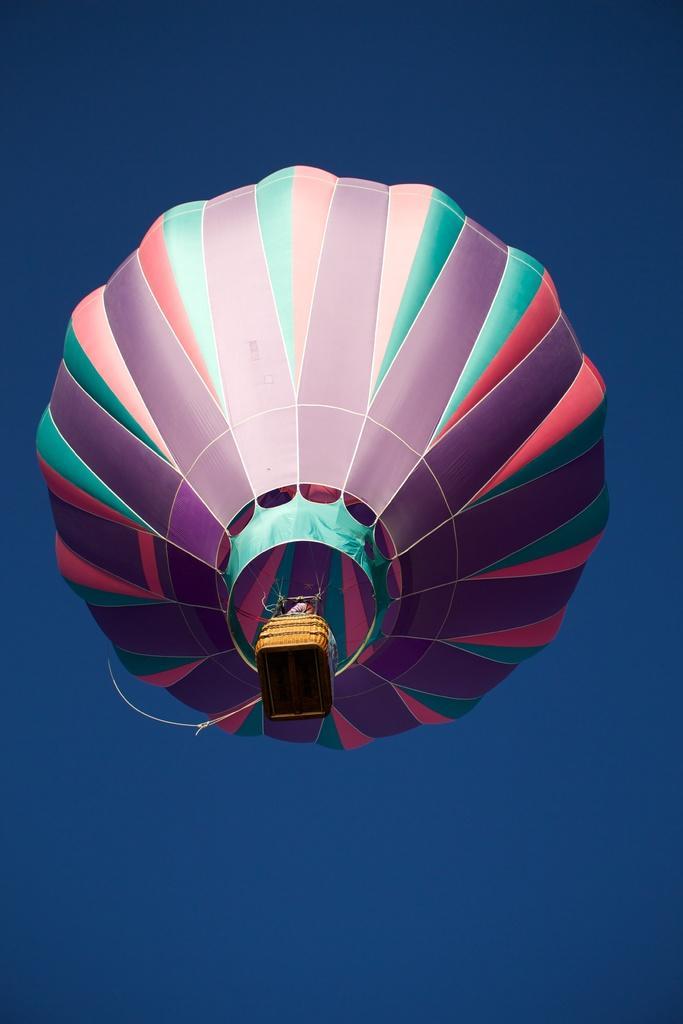Can you describe this image briefly? In the center of the image there is a air balloon in the air. In the background there is sky. 